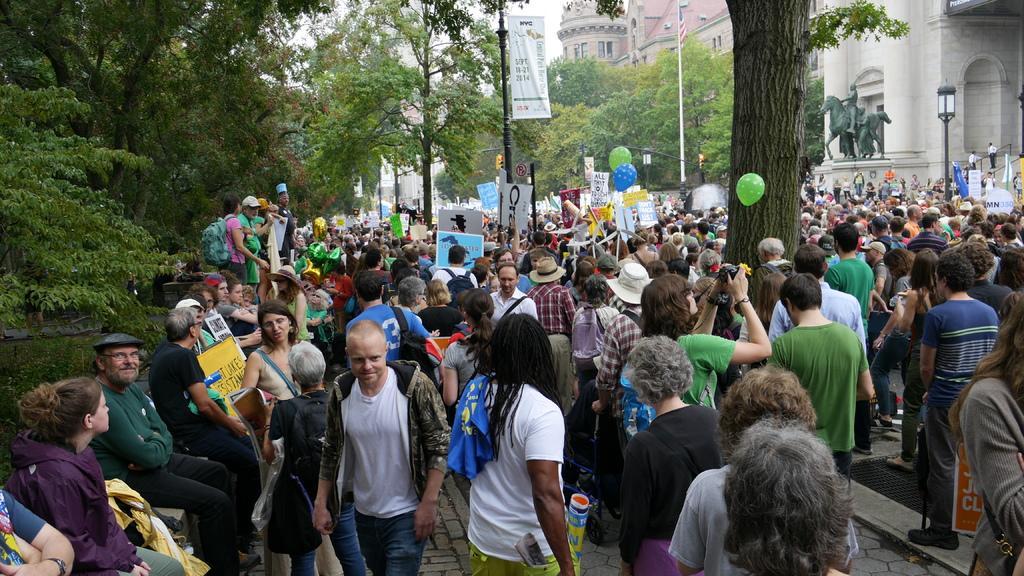Please provide a concise description of this image. At the bottom of the image we can see crowd. There are balloons and we can see boards. There are poles. In the background there are trees, buildings, statue and sky. 